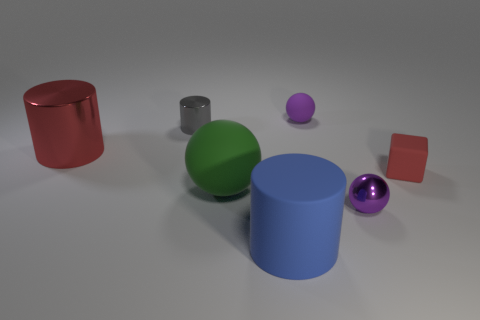Is there any other thing that has the same shape as the tiny red rubber object?
Keep it short and to the point. No. What is the color of the large cylinder that is the same material as the gray object?
Offer a terse response. Red. What color is the rubber thing on the right side of the small purple matte sphere?
Ensure brevity in your answer.  Red. How many big things have the same color as the rubber cube?
Give a very brief answer. 1. Are there fewer small red objects behind the big metallic thing than purple rubber objects that are behind the matte block?
Ensure brevity in your answer.  Yes. How many tiny metallic things are on the left side of the purple rubber object?
Offer a very short reply. 1. Are there any tiny purple things made of the same material as the red cube?
Provide a short and direct response. Yes. Are there more small purple shiny spheres that are in front of the large green rubber sphere than red metallic things that are to the right of the red block?
Ensure brevity in your answer.  Yes. The block is what size?
Provide a succinct answer. Small. There is a red thing that is on the left side of the gray cylinder; what shape is it?
Provide a succinct answer. Cylinder. 